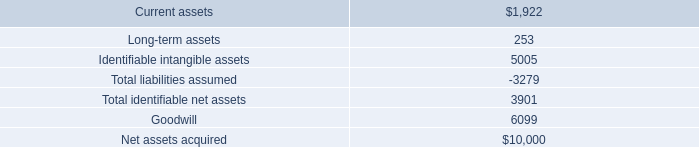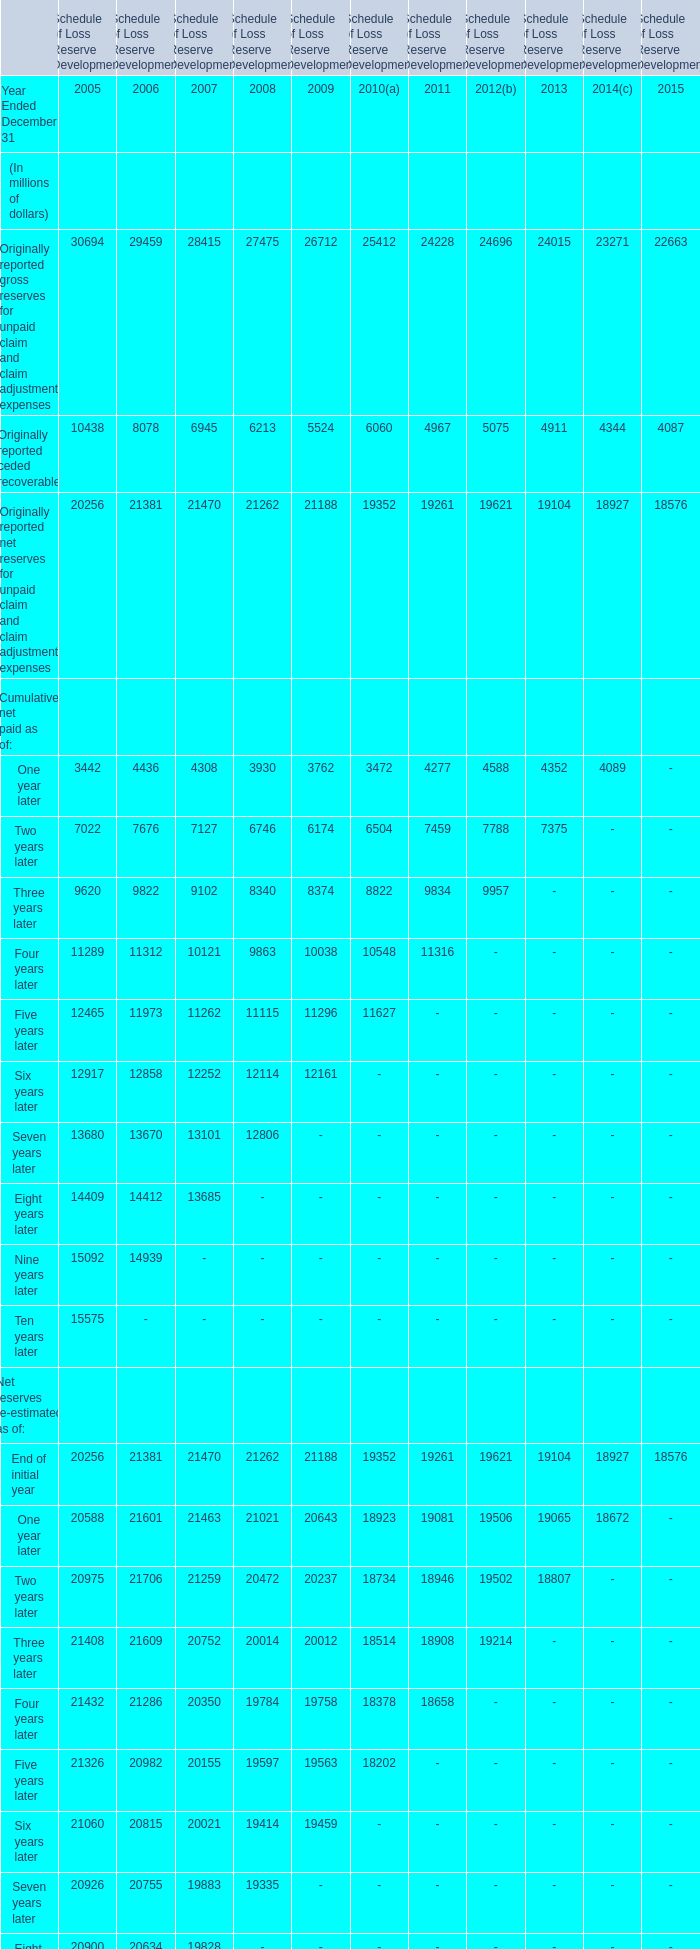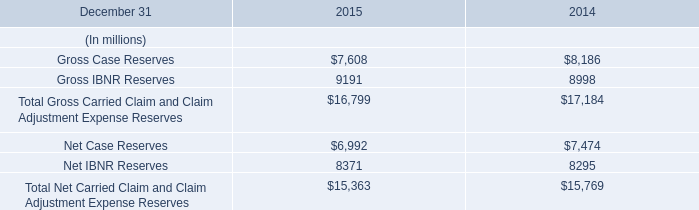what were net assets in millions acquired net of accounts receivable? 
Computations: (10000 - 178)
Answer: 9822.0. 